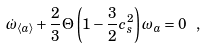<formula> <loc_0><loc_0><loc_500><loc_500>\dot { \omega } _ { \langle a \rangle } + { \frac { 2 } { 3 } } \Theta \left ( 1 - { \frac { 3 } { 2 } } c _ { s } ^ { 2 } \right ) \omega _ { a } = 0 \ ,</formula> 